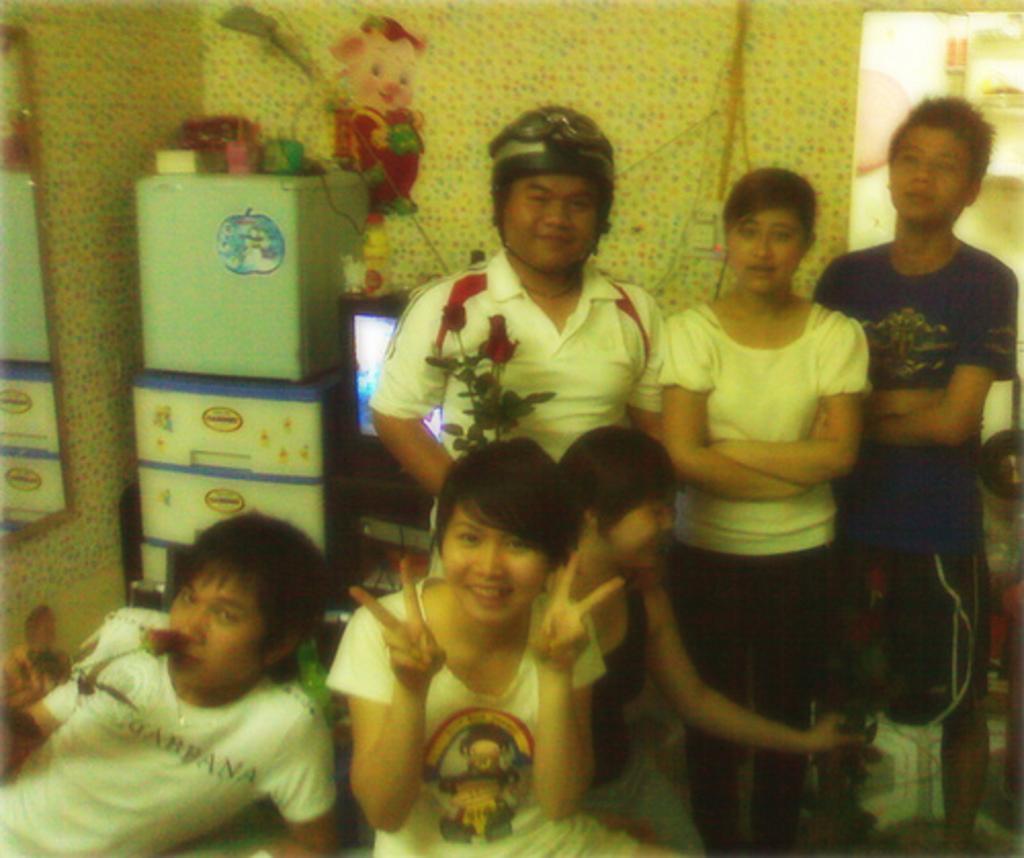Could you give a brief overview of what you see in this image? In this image we can see many persons sitting and standing. In the background we can see wall, refrigerator, cupboards, television, wires, stickers, mirror and door. 